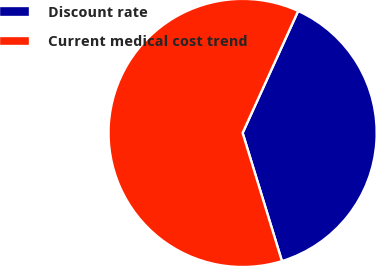<chart> <loc_0><loc_0><loc_500><loc_500><pie_chart><fcel>Discount rate<fcel>Current medical cost trend<nl><fcel>38.46%<fcel>61.54%<nl></chart> 